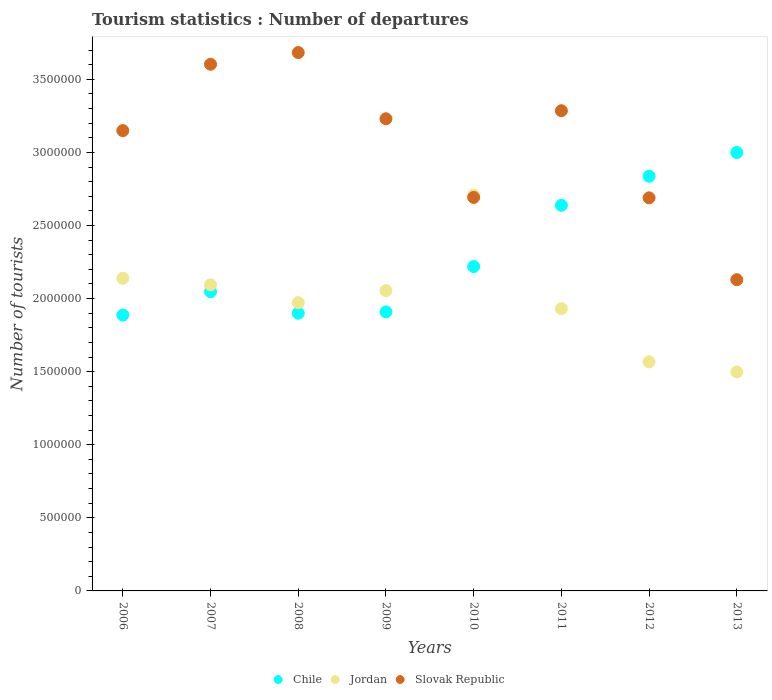What is the number of tourist departures in Jordan in 2007?
Give a very brief answer. 2.09e+06. Across all years, what is the maximum number of tourist departures in Chile?
Provide a short and direct response. 3.00e+06. Across all years, what is the minimum number of tourist departures in Chile?
Ensure brevity in your answer.  1.89e+06. In which year was the number of tourist departures in Jordan maximum?
Your answer should be compact. 2010. What is the total number of tourist departures in Jordan in the graph?
Offer a very short reply. 1.60e+07. What is the difference between the number of tourist departures in Jordan in 2006 and that in 2013?
Your answer should be very brief. 6.41e+05. What is the difference between the number of tourist departures in Jordan in 2007 and the number of tourist departures in Slovak Republic in 2009?
Your answer should be very brief. -1.14e+06. What is the average number of tourist departures in Slovak Republic per year?
Offer a very short reply. 3.06e+06. In the year 2007, what is the difference between the number of tourist departures in Jordan and number of tourist departures in Slovak Republic?
Give a very brief answer. -1.51e+06. In how many years, is the number of tourist departures in Chile greater than 1100000?
Offer a terse response. 8. What is the ratio of the number of tourist departures in Jordan in 2010 to that in 2011?
Your answer should be compact. 1.4. Is the number of tourist departures in Jordan in 2006 less than that in 2011?
Keep it short and to the point. No. Is the difference between the number of tourist departures in Jordan in 2006 and 2012 greater than the difference between the number of tourist departures in Slovak Republic in 2006 and 2012?
Your response must be concise. Yes. What is the difference between the highest and the second highest number of tourist departures in Jordan?
Provide a succinct answer. 5.69e+05. What is the difference between the highest and the lowest number of tourist departures in Jordan?
Offer a terse response. 1.21e+06. Is the sum of the number of tourist departures in Slovak Republic in 2008 and 2010 greater than the maximum number of tourist departures in Jordan across all years?
Make the answer very short. Yes. Does the number of tourist departures in Jordan monotonically increase over the years?
Keep it short and to the point. No. Is the number of tourist departures in Chile strictly less than the number of tourist departures in Jordan over the years?
Your response must be concise. No. How many dotlines are there?
Give a very brief answer. 3. How many legend labels are there?
Your answer should be compact. 3. How are the legend labels stacked?
Provide a short and direct response. Horizontal. What is the title of the graph?
Make the answer very short. Tourism statistics : Number of departures. Does "Faeroe Islands" appear as one of the legend labels in the graph?
Give a very brief answer. No. What is the label or title of the X-axis?
Make the answer very short. Years. What is the label or title of the Y-axis?
Offer a terse response. Number of tourists. What is the Number of tourists in Chile in 2006?
Keep it short and to the point. 1.89e+06. What is the Number of tourists of Jordan in 2006?
Make the answer very short. 2.14e+06. What is the Number of tourists in Slovak Republic in 2006?
Your answer should be compact. 3.15e+06. What is the Number of tourists of Chile in 2007?
Provide a short and direct response. 2.05e+06. What is the Number of tourists of Jordan in 2007?
Ensure brevity in your answer.  2.09e+06. What is the Number of tourists of Slovak Republic in 2007?
Make the answer very short. 3.60e+06. What is the Number of tourists in Chile in 2008?
Offer a very short reply. 1.90e+06. What is the Number of tourists in Jordan in 2008?
Make the answer very short. 1.97e+06. What is the Number of tourists of Slovak Republic in 2008?
Your response must be concise. 3.68e+06. What is the Number of tourists in Chile in 2009?
Your answer should be very brief. 1.91e+06. What is the Number of tourists of Jordan in 2009?
Ensure brevity in your answer.  2.05e+06. What is the Number of tourists in Slovak Republic in 2009?
Your response must be concise. 3.23e+06. What is the Number of tourists of Chile in 2010?
Your answer should be compact. 2.22e+06. What is the Number of tourists in Jordan in 2010?
Offer a very short reply. 2.71e+06. What is the Number of tourists of Slovak Republic in 2010?
Offer a very short reply. 2.69e+06. What is the Number of tourists of Chile in 2011?
Offer a very short reply. 2.64e+06. What is the Number of tourists of Jordan in 2011?
Keep it short and to the point. 1.93e+06. What is the Number of tourists of Slovak Republic in 2011?
Give a very brief answer. 3.28e+06. What is the Number of tourists of Chile in 2012?
Give a very brief answer. 2.84e+06. What is the Number of tourists in Jordan in 2012?
Ensure brevity in your answer.  1.57e+06. What is the Number of tourists of Slovak Republic in 2012?
Offer a very short reply. 2.69e+06. What is the Number of tourists in Chile in 2013?
Offer a terse response. 3.00e+06. What is the Number of tourists in Jordan in 2013?
Provide a short and direct response. 1.50e+06. What is the Number of tourists of Slovak Republic in 2013?
Offer a terse response. 2.13e+06. Across all years, what is the maximum Number of tourists in Chile?
Offer a very short reply. 3.00e+06. Across all years, what is the maximum Number of tourists of Jordan?
Make the answer very short. 2.71e+06. Across all years, what is the maximum Number of tourists of Slovak Republic?
Provide a succinct answer. 3.68e+06. Across all years, what is the minimum Number of tourists in Chile?
Your answer should be compact. 1.89e+06. Across all years, what is the minimum Number of tourists in Jordan?
Give a very brief answer. 1.50e+06. Across all years, what is the minimum Number of tourists in Slovak Republic?
Offer a terse response. 2.13e+06. What is the total Number of tourists in Chile in the graph?
Your response must be concise. 1.84e+07. What is the total Number of tourists of Jordan in the graph?
Your answer should be compact. 1.60e+07. What is the total Number of tourists in Slovak Republic in the graph?
Give a very brief answer. 2.45e+07. What is the difference between the Number of tourists in Jordan in 2006 and that in 2007?
Your answer should be very brief. 4.50e+04. What is the difference between the Number of tourists of Slovak Republic in 2006 and that in 2007?
Provide a short and direct response. -4.54e+05. What is the difference between the Number of tourists of Chile in 2006 and that in 2008?
Provide a short and direct response. -1.30e+04. What is the difference between the Number of tourists of Jordan in 2006 and that in 2008?
Give a very brief answer. 1.67e+05. What is the difference between the Number of tourists in Slovak Republic in 2006 and that in 2008?
Provide a succinct answer. -5.34e+05. What is the difference between the Number of tourists of Chile in 2006 and that in 2009?
Give a very brief answer. -2.20e+04. What is the difference between the Number of tourists of Jordan in 2006 and that in 2009?
Give a very brief answer. 8.50e+04. What is the difference between the Number of tourists of Slovak Republic in 2006 and that in 2009?
Provide a succinct answer. -8.10e+04. What is the difference between the Number of tourists of Chile in 2006 and that in 2010?
Provide a short and direct response. -3.32e+05. What is the difference between the Number of tourists of Jordan in 2006 and that in 2010?
Offer a terse response. -5.69e+05. What is the difference between the Number of tourists of Slovak Republic in 2006 and that in 2010?
Make the answer very short. 4.57e+05. What is the difference between the Number of tourists of Chile in 2006 and that in 2011?
Provide a short and direct response. -7.51e+05. What is the difference between the Number of tourists in Jordan in 2006 and that in 2011?
Provide a succinct answer. 2.08e+05. What is the difference between the Number of tourists in Slovak Republic in 2006 and that in 2011?
Provide a short and direct response. -1.36e+05. What is the difference between the Number of tourists of Chile in 2006 and that in 2012?
Your answer should be compact. -9.50e+05. What is the difference between the Number of tourists of Jordan in 2006 and that in 2012?
Provide a short and direct response. 5.72e+05. What is the difference between the Number of tourists of Slovak Republic in 2006 and that in 2012?
Offer a very short reply. 4.60e+05. What is the difference between the Number of tourists in Chile in 2006 and that in 2013?
Your response must be concise. -1.11e+06. What is the difference between the Number of tourists in Jordan in 2006 and that in 2013?
Offer a terse response. 6.41e+05. What is the difference between the Number of tourists of Slovak Republic in 2006 and that in 2013?
Provide a succinct answer. 1.02e+06. What is the difference between the Number of tourists in Chile in 2007 and that in 2008?
Ensure brevity in your answer.  1.47e+05. What is the difference between the Number of tourists in Jordan in 2007 and that in 2008?
Provide a succinct answer. 1.22e+05. What is the difference between the Number of tourists in Slovak Republic in 2007 and that in 2008?
Your response must be concise. -8.00e+04. What is the difference between the Number of tourists in Chile in 2007 and that in 2009?
Provide a succinct answer. 1.38e+05. What is the difference between the Number of tourists in Jordan in 2007 and that in 2009?
Offer a terse response. 4.00e+04. What is the difference between the Number of tourists in Slovak Republic in 2007 and that in 2009?
Keep it short and to the point. 3.73e+05. What is the difference between the Number of tourists in Chile in 2007 and that in 2010?
Ensure brevity in your answer.  -1.72e+05. What is the difference between the Number of tourists in Jordan in 2007 and that in 2010?
Offer a very short reply. -6.14e+05. What is the difference between the Number of tourists of Slovak Republic in 2007 and that in 2010?
Provide a succinct answer. 9.11e+05. What is the difference between the Number of tourists of Chile in 2007 and that in 2011?
Ensure brevity in your answer.  -5.91e+05. What is the difference between the Number of tourists of Jordan in 2007 and that in 2011?
Offer a very short reply. 1.63e+05. What is the difference between the Number of tourists in Slovak Republic in 2007 and that in 2011?
Give a very brief answer. 3.18e+05. What is the difference between the Number of tourists in Chile in 2007 and that in 2012?
Offer a very short reply. -7.90e+05. What is the difference between the Number of tourists in Jordan in 2007 and that in 2012?
Ensure brevity in your answer.  5.27e+05. What is the difference between the Number of tourists of Slovak Republic in 2007 and that in 2012?
Your answer should be very brief. 9.14e+05. What is the difference between the Number of tourists in Chile in 2007 and that in 2013?
Offer a very short reply. -9.52e+05. What is the difference between the Number of tourists of Jordan in 2007 and that in 2013?
Your response must be concise. 5.96e+05. What is the difference between the Number of tourists in Slovak Republic in 2007 and that in 2013?
Make the answer very short. 1.47e+06. What is the difference between the Number of tourists of Chile in 2008 and that in 2009?
Keep it short and to the point. -9000. What is the difference between the Number of tourists in Jordan in 2008 and that in 2009?
Make the answer very short. -8.20e+04. What is the difference between the Number of tourists of Slovak Republic in 2008 and that in 2009?
Offer a very short reply. 4.53e+05. What is the difference between the Number of tourists in Chile in 2008 and that in 2010?
Your response must be concise. -3.19e+05. What is the difference between the Number of tourists in Jordan in 2008 and that in 2010?
Offer a very short reply. -7.36e+05. What is the difference between the Number of tourists in Slovak Republic in 2008 and that in 2010?
Give a very brief answer. 9.91e+05. What is the difference between the Number of tourists in Chile in 2008 and that in 2011?
Keep it short and to the point. -7.38e+05. What is the difference between the Number of tourists of Jordan in 2008 and that in 2011?
Give a very brief answer. 4.10e+04. What is the difference between the Number of tourists of Slovak Republic in 2008 and that in 2011?
Provide a succinct answer. 3.98e+05. What is the difference between the Number of tourists in Chile in 2008 and that in 2012?
Provide a short and direct response. -9.37e+05. What is the difference between the Number of tourists of Jordan in 2008 and that in 2012?
Your answer should be compact. 4.05e+05. What is the difference between the Number of tourists of Slovak Republic in 2008 and that in 2012?
Provide a short and direct response. 9.94e+05. What is the difference between the Number of tourists in Chile in 2008 and that in 2013?
Provide a short and direct response. -1.10e+06. What is the difference between the Number of tourists of Jordan in 2008 and that in 2013?
Make the answer very short. 4.74e+05. What is the difference between the Number of tourists of Slovak Republic in 2008 and that in 2013?
Give a very brief answer. 1.55e+06. What is the difference between the Number of tourists of Chile in 2009 and that in 2010?
Your answer should be compact. -3.10e+05. What is the difference between the Number of tourists of Jordan in 2009 and that in 2010?
Provide a short and direct response. -6.54e+05. What is the difference between the Number of tourists of Slovak Republic in 2009 and that in 2010?
Make the answer very short. 5.38e+05. What is the difference between the Number of tourists of Chile in 2009 and that in 2011?
Provide a succinct answer. -7.29e+05. What is the difference between the Number of tourists of Jordan in 2009 and that in 2011?
Offer a terse response. 1.23e+05. What is the difference between the Number of tourists of Slovak Republic in 2009 and that in 2011?
Ensure brevity in your answer.  -5.50e+04. What is the difference between the Number of tourists of Chile in 2009 and that in 2012?
Make the answer very short. -9.28e+05. What is the difference between the Number of tourists in Jordan in 2009 and that in 2012?
Your answer should be compact. 4.87e+05. What is the difference between the Number of tourists of Slovak Republic in 2009 and that in 2012?
Your response must be concise. 5.41e+05. What is the difference between the Number of tourists in Chile in 2009 and that in 2013?
Your answer should be very brief. -1.09e+06. What is the difference between the Number of tourists of Jordan in 2009 and that in 2013?
Offer a terse response. 5.56e+05. What is the difference between the Number of tourists in Slovak Republic in 2009 and that in 2013?
Your answer should be compact. 1.10e+06. What is the difference between the Number of tourists of Chile in 2010 and that in 2011?
Provide a succinct answer. -4.19e+05. What is the difference between the Number of tourists of Jordan in 2010 and that in 2011?
Offer a very short reply. 7.77e+05. What is the difference between the Number of tourists of Slovak Republic in 2010 and that in 2011?
Your answer should be compact. -5.93e+05. What is the difference between the Number of tourists of Chile in 2010 and that in 2012?
Your answer should be compact. -6.18e+05. What is the difference between the Number of tourists of Jordan in 2010 and that in 2012?
Your answer should be compact. 1.14e+06. What is the difference between the Number of tourists of Slovak Republic in 2010 and that in 2012?
Make the answer very short. 3000. What is the difference between the Number of tourists in Chile in 2010 and that in 2013?
Make the answer very short. -7.80e+05. What is the difference between the Number of tourists of Jordan in 2010 and that in 2013?
Your answer should be compact. 1.21e+06. What is the difference between the Number of tourists of Slovak Republic in 2010 and that in 2013?
Give a very brief answer. 5.63e+05. What is the difference between the Number of tourists of Chile in 2011 and that in 2012?
Your response must be concise. -1.99e+05. What is the difference between the Number of tourists in Jordan in 2011 and that in 2012?
Offer a very short reply. 3.64e+05. What is the difference between the Number of tourists in Slovak Republic in 2011 and that in 2012?
Make the answer very short. 5.96e+05. What is the difference between the Number of tourists of Chile in 2011 and that in 2013?
Ensure brevity in your answer.  -3.61e+05. What is the difference between the Number of tourists in Jordan in 2011 and that in 2013?
Give a very brief answer. 4.33e+05. What is the difference between the Number of tourists in Slovak Republic in 2011 and that in 2013?
Provide a succinct answer. 1.16e+06. What is the difference between the Number of tourists in Chile in 2012 and that in 2013?
Offer a terse response. -1.62e+05. What is the difference between the Number of tourists in Jordan in 2012 and that in 2013?
Provide a short and direct response. 6.90e+04. What is the difference between the Number of tourists in Slovak Republic in 2012 and that in 2013?
Ensure brevity in your answer.  5.60e+05. What is the difference between the Number of tourists in Chile in 2006 and the Number of tourists in Jordan in 2007?
Offer a terse response. -2.07e+05. What is the difference between the Number of tourists of Chile in 2006 and the Number of tourists of Slovak Republic in 2007?
Ensure brevity in your answer.  -1.72e+06. What is the difference between the Number of tourists in Jordan in 2006 and the Number of tourists in Slovak Republic in 2007?
Provide a short and direct response. -1.46e+06. What is the difference between the Number of tourists of Chile in 2006 and the Number of tourists of Jordan in 2008?
Give a very brief answer. -8.50e+04. What is the difference between the Number of tourists of Chile in 2006 and the Number of tourists of Slovak Republic in 2008?
Your answer should be very brief. -1.80e+06. What is the difference between the Number of tourists of Jordan in 2006 and the Number of tourists of Slovak Republic in 2008?
Your answer should be very brief. -1.54e+06. What is the difference between the Number of tourists of Chile in 2006 and the Number of tourists of Jordan in 2009?
Ensure brevity in your answer.  -1.67e+05. What is the difference between the Number of tourists of Chile in 2006 and the Number of tourists of Slovak Republic in 2009?
Keep it short and to the point. -1.34e+06. What is the difference between the Number of tourists in Jordan in 2006 and the Number of tourists in Slovak Republic in 2009?
Provide a short and direct response. -1.09e+06. What is the difference between the Number of tourists in Chile in 2006 and the Number of tourists in Jordan in 2010?
Make the answer very short. -8.21e+05. What is the difference between the Number of tourists in Chile in 2006 and the Number of tourists in Slovak Republic in 2010?
Your answer should be very brief. -8.05e+05. What is the difference between the Number of tourists of Jordan in 2006 and the Number of tourists of Slovak Republic in 2010?
Provide a succinct answer. -5.53e+05. What is the difference between the Number of tourists in Chile in 2006 and the Number of tourists in Jordan in 2011?
Offer a very short reply. -4.40e+04. What is the difference between the Number of tourists of Chile in 2006 and the Number of tourists of Slovak Republic in 2011?
Ensure brevity in your answer.  -1.40e+06. What is the difference between the Number of tourists of Jordan in 2006 and the Number of tourists of Slovak Republic in 2011?
Keep it short and to the point. -1.15e+06. What is the difference between the Number of tourists of Chile in 2006 and the Number of tourists of Jordan in 2012?
Provide a short and direct response. 3.20e+05. What is the difference between the Number of tourists in Chile in 2006 and the Number of tourists in Slovak Republic in 2012?
Keep it short and to the point. -8.02e+05. What is the difference between the Number of tourists of Jordan in 2006 and the Number of tourists of Slovak Republic in 2012?
Keep it short and to the point. -5.50e+05. What is the difference between the Number of tourists in Chile in 2006 and the Number of tourists in Jordan in 2013?
Make the answer very short. 3.89e+05. What is the difference between the Number of tourists in Chile in 2006 and the Number of tourists in Slovak Republic in 2013?
Your response must be concise. -2.42e+05. What is the difference between the Number of tourists in Jordan in 2006 and the Number of tourists in Slovak Republic in 2013?
Keep it short and to the point. 10000. What is the difference between the Number of tourists of Chile in 2007 and the Number of tourists of Jordan in 2008?
Provide a succinct answer. 7.50e+04. What is the difference between the Number of tourists in Chile in 2007 and the Number of tourists in Slovak Republic in 2008?
Provide a short and direct response. -1.64e+06. What is the difference between the Number of tourists in Jordan in 2007 and the Number of tourists in Slovak Republic in 2008?
Ensure brevity in your answer.  -1.59e+06. What is the difference between the Number of tourists of Chile in 2007 and the Number of tourists of Jordan in 2009?
Give a very brief answer. -7000. What is the difference between the Number of tourists in Chile in 2007 and the Number of tourists in Slovak Republic in 2009?
Ensure brevity in your answer.  -1.18e+06. What is the difference between the Number of tourists of Jordan in 2007 and the Number of tourists of Slovak Republic in 2009?
Your answer should be very brief. -1.14e+06. What is the difference between the Number of tourists in Chile in 2007 and the Number of tourists in Jordan in 2010?
Offer a terse response. -6.61e+05. What is the difference between the Number of tourists in Chile in 2007 and the Number of tourists in Slovak Republic in 2010?
Provide a short and direct response. -6.45e+05. What is the difference between the Number of tourists in Jordan in 2007 and the Number of tourists in Slovak Republic in 2010?
Provide a short and direct response. -5.98e+05. What is the difference between the Number of tourists of Chile in 2007 and the Number of tourists of Jordan in 2011?
Ensure brevity in your answer.  1.16e+05. What is the difference between the Number of tourists of Chile in 2007 and the Number of tourists of Slovak Republic in 2011?
Provide a short and direct response. -1.24e+06. What is the difference between the Number of tourists in Jordan in 2007 and the Number of tourists in Slovak Republic in 2011?
Your answer should be compact. -1.19e+06. What is the difference between the Number of tourists in Chile in 2007 and the Number of tourists in Jordan in 2012?
Give a very brief answer. 4.80e+05. What is the difference between the Number of tourists of Chile in 2007 and the Number of tourists of Slovak Republic in 2012?
Provide a succinct answer. -6.42e+05. What is the difference between the Number of tourists in Jordan in 2007 and the Number of tourists in Slovak Republic in 2012?
Make the answer very short. -5.95e+05. What is the difference between the Number of tourists in Chile in 2007 and the Number of tourists in Jordan in 2013?
Keep it short and to the point. 5.49e+05. What is the difference between the Number of tourists in Chile in 2007 and the Number of tourists in Slovak Republic in 2013?
Offer a terse response. -8.20e+04. What is the difference between the Number of tourists of Jordan in 2007 and the Number of tourists of Slovak Republic in 2013?
Give a very brief answer. -3.50e+04. What is the difference between the Number of tourists of Chile in 2008 and the Number of tourists of Jordan in 2009?
Give a very brief answer. -1.54e+05. What is the difference between the Number of tourists of Chile in 2008 and the Number of tourists of Slovak Republic in 2009?
Offer a very short reply. -1.33e+06. What is the difference between the Number of tourists in Jordan in 2008 and the Number of tourists in Slovak Republic in 2009?
Your response must be concise. -1.26e+06. What is the difference between the Number of tourists of Chile in 2008 and the Number of tourists of Jordan in 2010?
Give a very brief answer. -8.08e+05. What is the difference between the Number of tourists in Chile in 2008 and the Number of tourists in Slovak Republic in 2010?
Provide a short and direct response. -7.92e+05. What is the difference between the Number of tourists in Jordan in 2008 and the Number of tourists in Slovak Republic in 2010?
Your answer should be compact. -7.20e+05. What is the difference between the Number of tourists in Chile in 2008 and the Number of tourists in Jordan in 2011?
Keep it short and to the point. -3.10e+04. What is the difference between the Number of tourists of Chile in 2008 and the Number of tourists of Slovak Republic in 2011?
Make the answer very short. -1.38e+06. What is the difference between the Number of tourists of Jordan in 2008 and the Number of tourists of Slovak Republic in 2011?
Give a very brief answer. -1.31e+06. What is the difference between the Number of tourists in Chile in 2008 and the Number of tourists in Jordan in 2012?
Provide a succinct answer. 3.33e+05. What is the difference between the Number of tourists in Chile in 2008 and the Number of tourists in Slovak Republic in 2012?
Give a very brief answer. -7.89e+05. What is the difference between the Number of tourists of Jordan in 2008 and the Number of tourists of Slovak Republic in 2012?
Your answer should be compact. -7.17e+05. What is the difference between the Number of tourists in Chile in 2008 and the Number of tourists in Jordan in 2013?
Provide a short and direct response. 4.02e+05. What is the difference between the Number of tourists of Chile in 2008 and the Number of tourists of Slovak Republic in 2013?
Provide a succinct answer. -2.29e+05. What is the difference between the Number of tourists of Jordan in 2008 and the Number of tourists of Slovak Republic in 2013?
Keep it short and to the point. -1.57e+05. What is the difference between the Number of tourists of Chile in 2009 and the Number of tourists of Jordan in 2010?
Your answer should be very brief. -7.99e+05. What is the difference between the Number of tourists in Chile in 2009 and the Number of tourists in Slovak Republic in 2010?
Your answer should be very brief. -7.83e+05. What is the difference between the Number of tourists of Jordan in 2009 and the Number of tourists of Slovak Republic in 2010?
Provide a succinct answer. -6.38e+05. What is the difference between the Number of tourists in Chile in 2009 and the Number of tourists in Jordan in 2011?
Your answer should be compact. -2.20e+04. What is the difference between the Number of tourists in Chile in 2009 and the Number of tourists in Slovak Republic in 2011?
Offer a terse response. -1.38e+06. What is the difference between the Number of tourists of Jordan in 2009 and the Number of tourists of Slovak Republic in 2011?
Your answer should be very brief. -1.23e+06. What is the difference between the Number of tourists in Chile in 2009 and the Number of tourists in Jordan in 2012?
Provide a short and direct response. 3.42e+05. What is the difference between the Number of tourists in Chile in 2009 and the Number of tourists in Slovak Republic in 2012?
Provide a succinct answer. -7.80e+05. What is the difference between the Number of tourists of Jordan in 2009 and the Number of tourists of Slovak Republic in 2012?
Give a very brief answer. -6.35e+05. What is the difference between the Number of tourists of Chile in 2009 and the Number of tourists of Jordan in 2013?
Provide a succinct answer. 4.11e+05. What is the difference between the Number of tourists in Jordan in 2009 and the Number of tourists in Slovak Republic in 2013?
Provide a short and direct response. -7.50e+04. What is the difference between the Number of tourists in Chile in 2010 and the Number of tourists in Jordan in 2011?
Offer a terse response. 2.88e+05. What is the difference between the Number of tourists in Chile in 2010 and the Number of tourists in Slovak Republic in 2011?
Your answer should be compact. -1.07e+06. What is the difference between the Number of tourists in Jordan in 2010 and the Number of tourists in Slovak Republic in 2011?
Offer a very short reply. -5.77e+05. What is the difference between the Number of tourists of Chile in 2010 and the Number of tourists of Jordan in 2012?
Make the answer very short. 6.52e+05. What is the difference between the Number of tourists in Chile in 2010 and the Number of tourists in Slovak Republic in 2012?
Make the answer very short. -4.70e+05. What is the difference between the Number of tourists in Jordan in 2010 and the Number of tourists in Slovak Republic in 2012?
Provide a short and direct response. 1.90e+04. What is the difference between the Number of tourists in Chile in 2010 and the Number of tourists in Jordan in 2013?
Offer a terse response. 7.21e+05. What is the difference between the Number of tourists in Chile in 2010 and the Number of tourists in Slovak Republic in 2013?
Ensure brevity in your answer.  9.00e+04. What is the difference between the Number of tourists in Jordan in 2010 and the Number of tourists in Slovak Republic in 2013?
Make the answer very short. 5.79e+05. What is the difference between the Number of tourists in Chile in 2011 and the Number of tourists in Jordan in 2012?
Your response must be concise. 1.07e+06. What is the difference between the Number of tourists in Chile in 2011 and the Number of tourists in Slovak Republic in 2012?
Provide a succinct answer. -5.10e+04. What is the difference between the Number of tourists in Jordan in 2011 and the Number of tourists in Slovak Republic in 2012?
Ensure brevity in your answer.  -7.58e+05. What is the difference between the Number of tourists of Chile in 2011 and the Number of tourists of Jordan in 2013?
Make the answer very short. 1.14e+06. What is the difference between the Number of tourists of Chile in 2011 and the Number of tourists of Slovak Republic in 2013?
Your response must be concise. 5.09e+05. What is the difference between the Number of tourists in Jordan in 2011 and the Number of tourists in Slovak Republic in 2013?
Provide a short and direct response. -1.98e+05. What is the difference between the Number of tourists in Chile in 2012 and the Number of tourists in Jordan in 2013?
Give a very brief answer. 1.34e+06. What is the difference between the Number of tourists in Chile in 2012 and the Number of tourists in Slovak Republic in 2013?
Make the answer very short. 7.08e+05. What is the difference between the Number of tourists of Jordan in 2012 and the Number of tourists of Slovak Republic in 2013?
Provide a succinct answer. -5.62e+05. What is the average Number of tourists of Chile per year?
Your answer should be compact. 2.30e+06. What is the average Number of tourists of Jordan per year?
Provide a short and direct response. 2.00e+06. What is the average Number of tourists of Slovak Republic per year?
Your answer should be very brief. 3.06e+06. In the year 2006, what is the difference between the Number of tourists in Chile and Number of tourists in Jordan?
Your response must be concise. -2.52e+05. In the year 2006, what is the difference between the Number of tourists in Chile and Number of tourists in Slovak Republic?
Keep it short and to the point. -1.26e+06. In the year 2006, what is the difference between the Number of tourists of Jordan and Number of tourists of Slovak Republic?
Make the answer very short. -1.01e+06. In the year 2007, what is the difference between the Number of tourists of Chile and Number of tourists of Jordan?
Provide a short and direct response. -4.70e+04. In the year 2007, what is the difference between the Number of tourists of Chile and Number of tourists of Slovak Republic?
Your response must be concise. -1.56e+06. In the year 2007, what is the difference between the Number of tourists of Jordan and Number of tourists of Slovak Republic?
Ensure brevity in your answer.  -1.51e+06. In the year 2008, what is the difference between the Number of tourists in Chile and Number of tourists in Jordan?
Offer a very short reply. -7.20e+04. In the year 2008, what is the difference between the Number of tourists of Chile and Number of tourists of Slovak Republic?
Keep it short and to the point. -1.78e+06. In the year 2008, what is the difference between the Number of tourists in Jordan and Number of tourists in Slovak Republic?
Give a very brief answer. -1.71e+06. In the year 2009, what is the difference between the Number of tourists of Chile and Number of tourists of Jordan?
Give a very brief answer. -1.45e+05. In the year 2009, what is the difference between the Number of tourists of Chile and Number of tourists of Slovak Republic?
Provide a short and direct response. -1.32e+06. In the year 2009, what is the difference between the Number of tourists in Jordan and Number of tourists in Slovak Republic?
Give a very brief answer. -1.18e+06. In the year 2010, what is the difference between the Number of tourists in Chile and Number of tourists in Jordan?
Give a very brief answer. -4.89e+05. In the year 2010, what is the difference between the Number of tourists of Chile and Number of tourists of Slovak Republic?
Provide a short and direct response. -4.73e+05. In the year 2010, what is the difference between the Number of tourists in Jordan and Number of tourists in Slovak Republic?
Give a very brief answer. 1.60e+04. In the year 2011, what is the difference between the Number of tourists in Chile and Number of tourists in Jordan?
Offer a terse response. 7.07e+05. In the year 2011, what is the difference between the Number of tourists of Chile and Number of tourists of Slovak Republic?
Your answer should be compact. -6.47e+05. In the year 2011, what is the difference between the Number of tourists of Jordan and Number of tourists of Slovak Republic?
Make the answer very short. -1.35e+06. In the year 2012, what is the difference between the Number of tourists in Chile and Number of tourists in Jordan?
Make the answer very short. 1.27e+06. In the year 2012, what is the difference between the Number of tourists of Chile and Number of tourists of Slovak Republic?
Your response must be concise. 1.48e+05. In the year 2012, what is the difference between the Number of tourists in Jordan and Number of tourists in Slovak Republic?
Give a very brief answer. -1.12e+06. In the year 2013, what is the difference between the Number of tourists in Chile and Number of tourists in Jordan?
Offer a terse response. 1.50e+06. In the year 2013, what is the difference between the Number of tourists in Chile and Number of tourists in Slovak Republic?
Provide a short and direct response. 8.70e+05. In the year 2013, what is the difference between the Number of tourists in Jordan and Number of tourists in Slovak Republic?
Ensure brevity in your answer.  -6.31e+05. What is the ratio of the Number of tourists in Chile in 2006 to that in 2007?
Offer a terse response. 0.92. What is the ratio of the Number of tourists in Jordan in 2006 to that in 2007?
Offer a terse response. 1.02. What is the ratio of the Number of tourists of Slovak Republic in 2006 to that in 2007?
Ensure brevity in your answer.  0.87. What is the ratio of the Number of tourists of Jordan in 2006 to that in 2008?
Provide a short and direct response. 1.08. What is the ratio of the Number of tourists in Slovak Republic in 2006 to that in 2008?
Provide a succinct answer. 0.85. What is the ratio of the Number of tourists of Jordan in 2006 to that in 2009?
Provide a short and direct response. 1.04. What is the ratio of the Number of tourists in Slovak Republic in 2006 to that in 2009?
Give a very brief answer. 0.97. What is the ratio of the Number of tourists in Chile in 2006 to that in 2010?
Your answer should be very brief. 0.85. What is the ratio of the Number of tourists in Jordan in 2006 to that in 2010?
Make the answer very short. 0.79. What is the ratio of the Number of tourists in Slovak Republic in 2006 to that in 2010?
Ensure brevity in your answer.  1.17. What is the ratio of the Number of tourists in Chile in 2006 to that in 2011?
Your response must be concise. 0.72. What is the ratio of the Number of tourists of Jordan in 2006 to that in 2011?
Make the answer very short. 1.11. What is the ratio of the Number of tourists in Slovak Republic in 2006 to that in 2011?
Keep it short and to the point. 0.96. What is the ratio of the Number of tourists of Chile in 2006 to that in 2012?
Offer a very short reply. 0.67. What is the ratio of the Number of tourists in Jordan in 2006 to that in 2012?
Provide a short and direct response. 1.36. What is the ratio of the Number of tourists of Slovak Republic in 2006 to that in 2012?
Your answer should be compact. 1.17. What is the ratio of the Number of tourists of Chile in 2006 to that in 2013?
Provide a succinct answer. 0.63. What is the ratio of the Number of tourists of Jordan in 2006 to that in 2013?
Your answer should be compact. 1.43. What is the ratio of the Number of tourists in Slovak Republic in 2006 to that in 2013?
Your answer should be very brief. 1.48. What is the ratio of the Number of tourists in Chile in 2007 to that in 2008?
Ensure brevity in your answer.  1.08. What is the ratio of the Number of tourists in Jordan in 2007 to that in 2008?
Offer a very short reply. 1.06. What is the ratio of the Number of tourists in Slovak Republic in 2007 to that in 2008?
Your response must be concise. 0.98. What is the ratio of the Number of tourists in Chile in 2007 to that in 2009?
Provide a short and direct response. 1.07. What is the ratio of the Number of tourists in Jordan in 2007 to that in 2009?
Provide a short and direct response. 1.02. What is the ratio of the Number of tourists in Slovak Republic in 2007 to that in 2009?
Provide a short and direct response. 1.12. What is the ratio of the Number of tourists in Chile in 2007 to that in 2010?
Give a very brief answer. 0.92. What is the ratio of the Number of tourists of Jordan in 2007 to that in 2010?
Provide a succinct answer. 0.77. What is the ratio of the Number of tourists in Slovak Republic in 2007 to that in 2010?
Keep it short and to the point. 1.34. What is the ratio of the Number of tourists of Chile in 2007 to that in 2011?
Your answer should be very brief. 0.78. What is the ratio of the Number of tourists in Jordan in 2007 to that in 2011?
Your response must be concise. 1.08. What is the ratio of the Number of tourists of Slovak Republic in 2007 to that in 2011?
Keep it short and to the point. 1.1. What is the ratio of the Number of tourists of Chile in 2007 to that in 2012?
Offer a very short reply. 0.72. What is the ratio of the Number of tourists of Jordan in 2007 to that in 2012?
Provide a short and direct response. 1.34. What is the ratio of the Number of tourists of Slovak Republic in 2007 to that in 2012?
Make the answer very short. 1.34. What is the ratio of the Number of tourists of Chile in 2007 to that in 2013?
Your answer should be very brief. 0.68. What is the ratio of the Number of tourists of Jordan in 2007 to that in 2013?
Provide a short and direct response. 1.4. What is the ratio of the Number of tourists in Slovak Republic in 2007 to that in 2013?
Offer a terse response. 1.69. What is the ratio of the Number of tourists in Jordan in 2008 to that in 2009?
Offer a terse response. 0.96. What is the ratio of the Number of tourists in Slovak Republic in 2008 to that in 2009?
Your answer should be compact. 1.14. What is the ratio of the Number of tourists in Chile in 2008 to that in 2010?
Make the answer very short. 0.86. What is the ratio of the Number of tourists in Jordan in 2008 to that in 2010?
Provide a short and direct response. 0.73. What is the ratio of the Number of tourists in Slovak Republic in 2008 to that in 2010?
Provide a succinct answer. 1.37. What is the ratio of the Number of tourists in Chile in 2008 to that in 2011?
Give a very brief answer. 0.72. What is the ratio of the Number of tourists of Jordan in 2008 to that in 2011?
Your response must be concise. 1.02. What is the ratio of the Number of tourists in Slovak Republic in 2008 to that in 2011?
Provide a short and direct response. 1.12. What is the ratio of the Number of tourists of Chile in 2008 to that in 2012?
Keep it short and to the point. 0.67. What is the ratio of the Number of tourists of Jordan in 2008 to that in 2012?
Provide a succinct answer. 1.26. What is the ratio of the Number of tourists of Slovak Republic in 2008 to that in 2012?
Give a very brief answer. 1.37. What is the ratio of the Number of tourists of Chile in 2008 to that in 2013?
Offer a terse response. 0.63. What is the ratio of the Number of tourists in Jordan in 2008 to that in 2013?
Ensure brevity in your answer.  1.32. What is the ratio of the Number of tourists of Slovak Republic in 2008 to that in 2013?
Ensure brevity in your answer.  1.73. What is the ratio of the Number of tourists of Chile in 2009 to that in 2010?
Offer a very short reply. 0.86. What is the ratio of the Number of tourists of Jordan in 2009 to that in 2010?
Offer a terse response. 0.76. What is the ratio of the Number of tourists in Slovak Republic in 2009 to that in 2010?
Provide a short and direct response. 1.2. What is the ratio of the Number of tourists of Chile in 2009 to that in 2011?
Make the answer very short. 0.72. What is the ratio of the Number of tourists in Jordan in 2009 to that in 2011?
Your answer should be very brief. 1.06. What is the ratio of the Number of tourists of Slovak Republic in 2009 to that in 2011?
Your response must be concise. 0.98. What is the ratio of the Number of tourists in Chile in 2009 to that in 2012?
Offer a terse response. 0.67. What is the ratio of the Number of tourists in Jordan in 2009 to that in 2012?
Make the answer very short. 1.31. What is the ratio of the Number of tourists of Slovak Republic in 2009 to that in 2012?
Provide a short and direct response. 1.2. What is the ratio of the Number of tourists of Chile in 2009 to that in 2013?
Offer a very short reply. 0.64. What is the ratio of the Number of tourists of Jordan in 2009 to that in 2013?
Give a very brief answer. 1.37. What is the ratio of the Number of tourists in Slovak Republic in 2009 to that in 2013?
Provide a short and direct response. 1.52. What is the ratio of the Number of tourists in Chile in 2010 to that in 2011?
Make the answer very short. 0.84. What is the ratio of the Number of tourists of Jordan in 2010 to that in 2011?
Ensure brevity in your answer.  1.4. What is the ratio of the Number of tourists of Slovak Republic in 2010 to that in 2011?
Your answer should be very brief. 0.82. What is the ratio of the Number of tourists in Chile in 2010 to that in 2012?
Your answer should be very brief. 0.78. What is the ratio of the Number of tourists in Jordan in 2010 to that in 2012?
Keep it short and to the point. 1.73. What is the ratio of the Number of tourists of Slovak Republic in 2010 to that in 2012?
Offer a terse response. 1. What is the ratio of the Number of tourists of Chile in 2010 to that in 2013?
Provide a short and direct response. 0.74. What is the ratio of the Number of tourists of Jordan in 2010 to that in 2013?
Your response must be concise. 1.81. What is the ratio of the Number of tourists of Slovak Republic in 2010 to that in 2013?
Offer a terse response. 1.26. What is the ratio of the Number of tourists of Chile in 2011 to that in 2012?
Provide a succinct answer. 0.93. What is the ratio of the Number of tourists in Jordan in 2011 to that in 2012?
Your response must be concise. 1.23. What is the ratio of the Number of tourists in Slovak Republic in 2011 to that in 2012?
Provide a succinct answer. 1.22. What is the ratio of the Number of tourists of Chile in 2011 to that in 2013?
Give a very brief answer. 0.88. What is the ratio of the Number of tourists in Jordan in 2011 to that in 2013?
Make the answer very short. 1.29. What is the ratio of the Number of tourists in Slovak Republic in 2011 to that in 2013?
Offer a very short reply. 1.54. What is the ratio of the Number of tourists of Chile in 2012 to that in 2013?
Provide a succinct answer. 0.95. What is the ratio of the Number of tourists in Jordan in 2012 to that in 2013?
Your answer should be compact. 1.05. What is the ratio of the Number of tourists of Slovak Republic in 2012 to that in 2013?
Ensure brevity in your answer.  1.26. What is the difference between the highest and the second highest Number of tourists of Chile?
Give a very brief answer. 1.62e+05. What is the difference between the highest and the second highest Number of tourists of Jordan?
Keep it short and to the point. 5.69e+05. What is the difference between the highest and the lowest Number of tourists of Chile?
Provide a short and direct response. 1.11e+06. What is the difference between the highest and the lowest Number of tourists of Jordan?
Provide a short and direct response. 1.21e+06. What is the difference between the highest and the lowest Number of tourists of Slovak Republic?
Make the answer very short. 1.55e+06. 